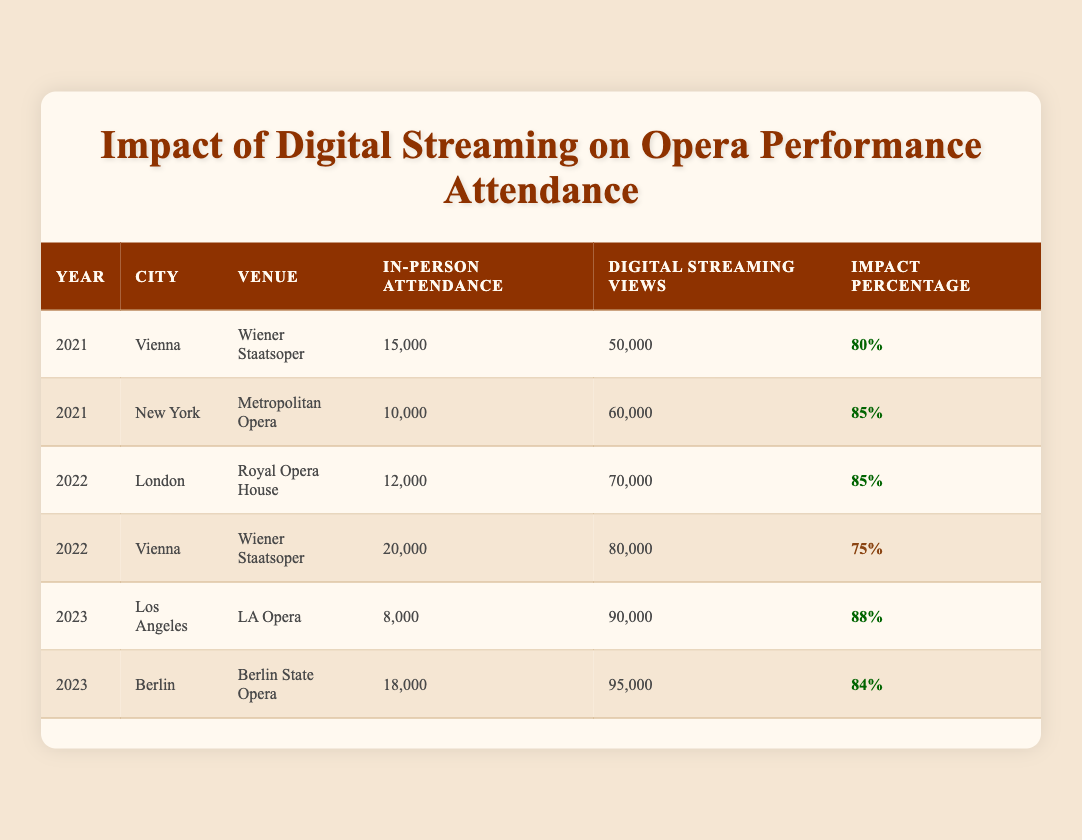What was the highest in-person attendance in 2022? In 2022, the in-person attendance at Wiener Staatsoper in Vienna was 20,000, which is higher than the 12,000 at Royal Opera House in London. Therefore, the highest in-person attendance in 2022 is 20,000.
Answer: 20,000 What was the impact percentage for the Metropolitan Opera in 2021? The impact percentage for the Metropolitan Opera in 2021 is listed directly in the table as 85%.
Answer: 85% Which city had the lowest in-person attendance in 2023? In 2023, Los Angeles had the lowest in-person attendance with 8,000 at the LA Opera, compared to 18,000 at the Berlin State Opera.
Answer: 8,000 What is the average impact percentage across all venues in 2021? The impact percentages for 2021 are 80% for Wiener Staatsoper and 85% for Metropolitan Opera. The average is calculated as (80 + 85) / 2 = 82.5.
Answer: 82.5 Is it true that in every year, digital streaming views exceeded in-person attendance? Yes, in every year listed, digital streaming views (50,000; 60,000; 70,000; 80,000; 90,000; 95,000) exceeded in-person attendance (15,000; 10,000; 12,000; 20,000; 8,000; 18,000).
Answer: Yes What was the total digital streaming views in 2022? The digital streaming views for 2022 were 70,000 for the Royal Opera House and 80,000 for Wiener Staatsoper, which sums up to 70,000 + 80,000 = 150,000.
Answer: 150,000 Which venue had the highest digital streaming views in 2023? In 2023, the LA Opera had 90,000 digital streaming views, while the Berlin State Opera had 95,000. Therefore, the Berlin State Opera had the highest views in that year.
Answer: 95,000 What was the change in in-person attendance from 2021 to 2022 for the Wiener Staatsoper? The attendance for Wiener Staatsoper increased from 15,000 in 2021 to 20,000 in 2022, which is a change of 20,000 - 15,000 = 5,000.
Answer: 5,000 In which year was the digital streaming impact percentage the lowest? In the table, the impact percentage for Wiener Staatsoper in 2022 is 75%, which is lower than the percentages in other years. Hence, 2022 had the lowest impact percentage.
Answer: 2022 